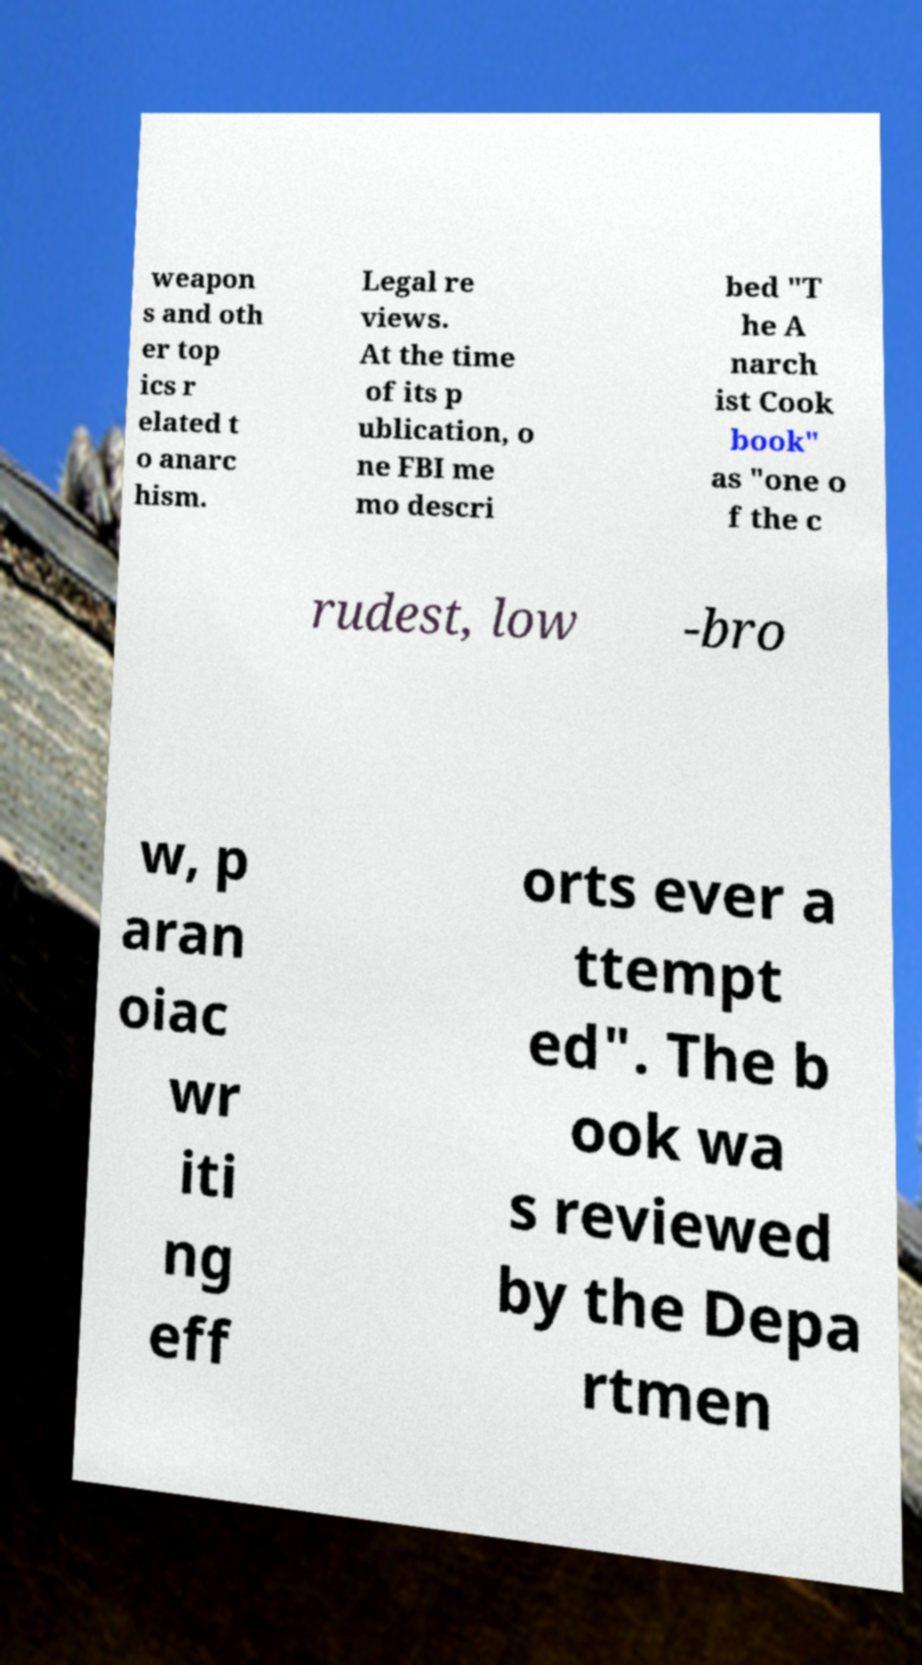Please read and relay the text visible in this image. What does it say? weapon s and oth er top ics r elated t o anarc hism. Legal re views. At the time of its p ublication, o ne FBI me mo descri bed "T he A narch ist Cook book" as "one o f the c rudest, low -bro w, p aran oiac wr iti ng eff orts ever a ttempt ed". The b ook wa s reviewed by the Depa rtmen 